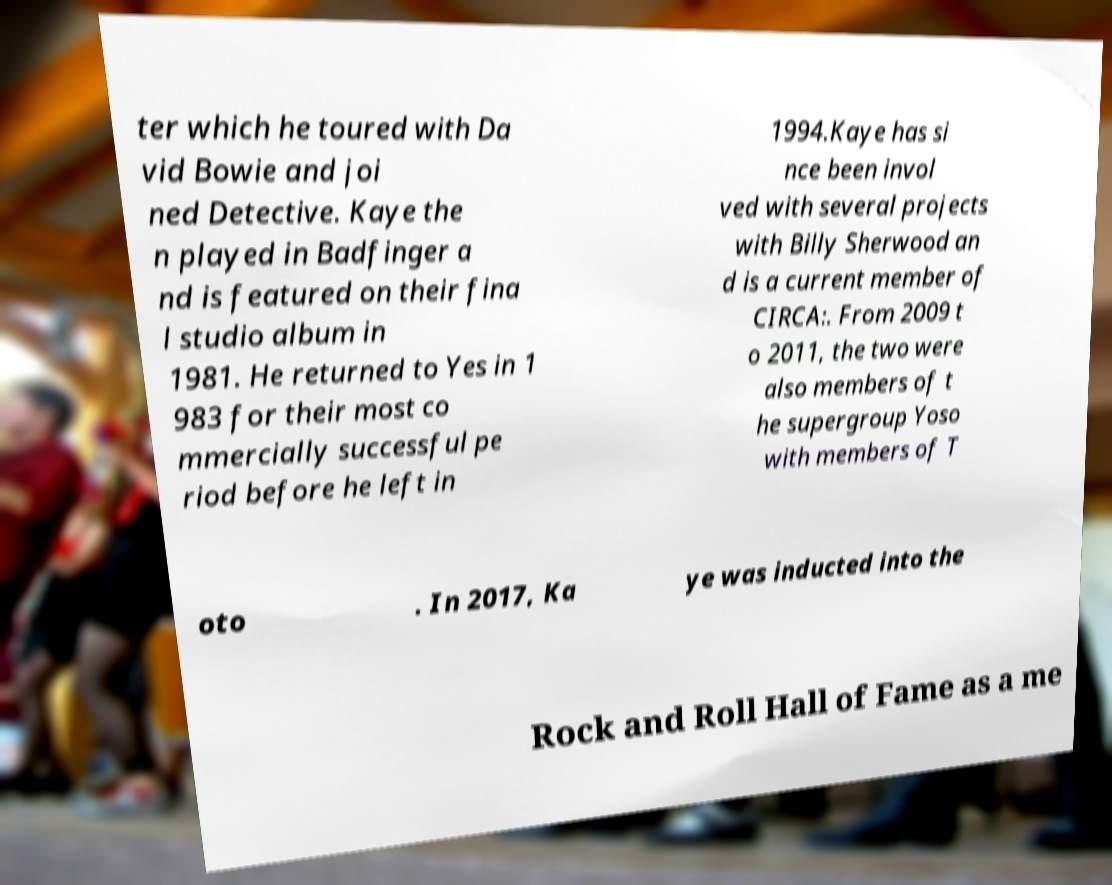Can you accurately transcribe the text from the provided image for me? ter which he toured with Da vid Bowie and joi ned Detective. Kaye the n played in Badfinger a nd is featured on their fina l studio album in 1981. He returned to Yes in 1 983 for their most co mmercially successful pe riod before he left in 1994.Kaye has si nce been invol ved with several projects with Billy Sherwood an d is a current member of CIRCA:. From 2009 t o 2011, the two were also members of t he supergroup Yoso with members of T oto . In 2017, Ka ye was inducted into the Rock and Roll Hall of Fame as a me 